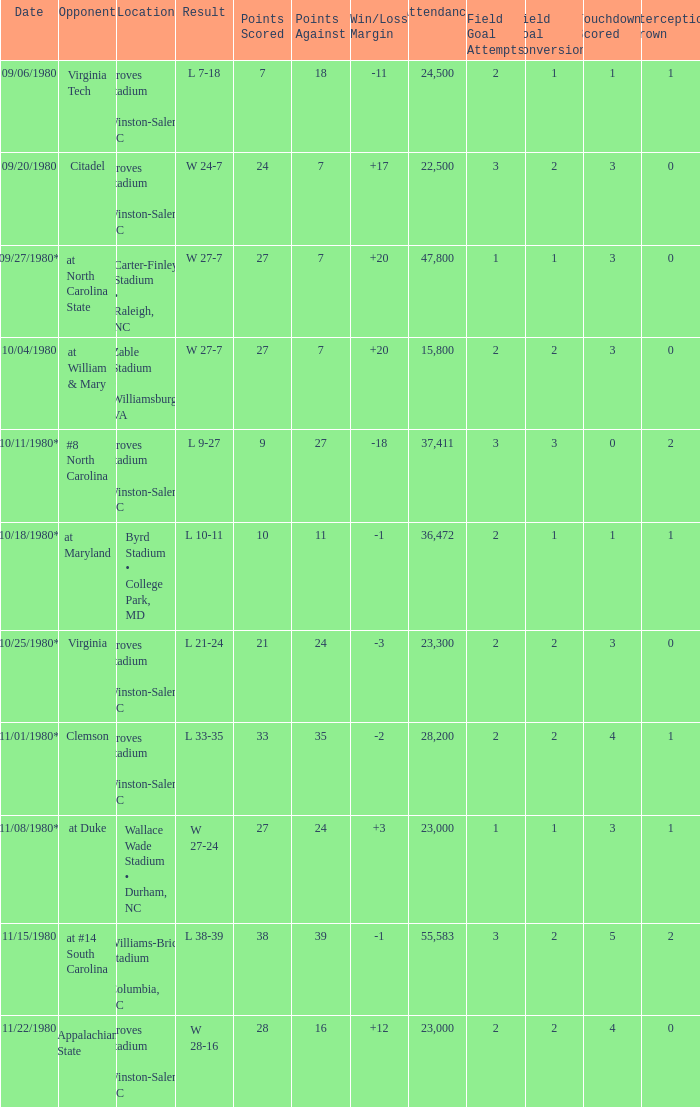How many people attended when Wake Forest played Virginia Tech? 24500.0. 